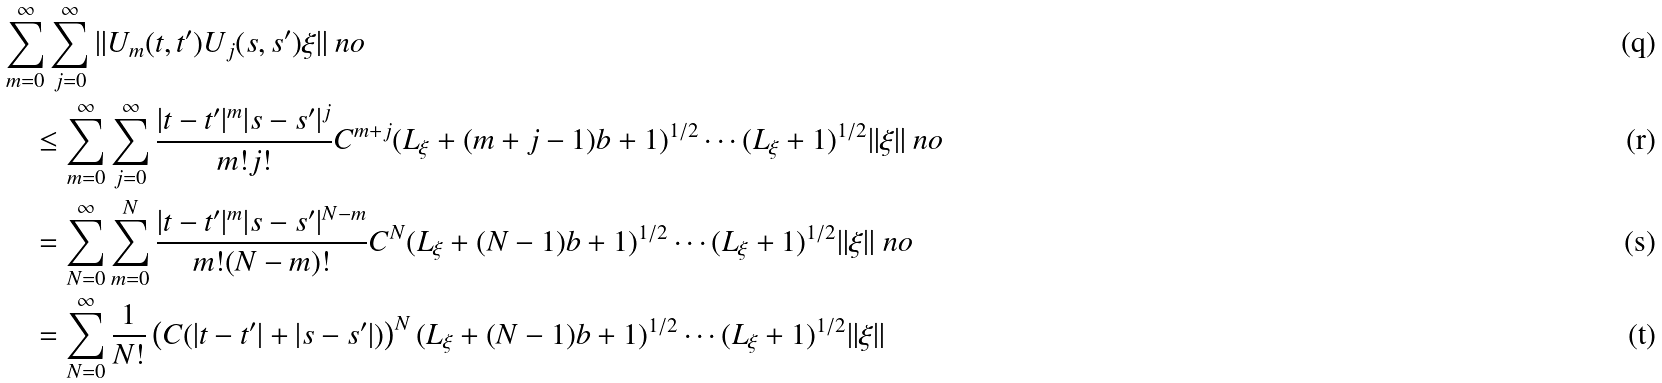<formula> <loc_0><loc_0><loc_500><loc_500>& \sum _ { m = 0 } ^ { \infty } \sum _ { j = 0 } ^ { \infty } \| U _ { m } ( t , t ^ { \prime } ) U _ { j } ( s , s ^ { \prime } ) \xi \| \ n o \\ & \quad \leq \sum _ { m = 0 } ^ { \infty } \sum _ { j = 0 } ^ { \infty } \frac { | t - t ^ { \prime } | ^ { m } | s - s ^ { \prime } | ^ { j } } { m ! j ! } C ^ { m + j } ( L _ { \xi } + ( m + j - 1 ) b + 1 ) ^ { 1 / 2 } \cdots ( L _ { \xi } + 1 ) ^ { 1 / 2 } \| \xi \| \ n o \\ & \quad = \sum _ { N = 0 } ^ { \infty } \sum _ { m = 0 } ^ { N } \frac { | t - t ^ { \prime } | ^ { m } | s - s ^ { \prime } | ^ { N - m } } { m ! ( N - m ) ! } C ^ { N } ( L _ { \xi } + ( N - 1 ) b + 1 ) ^ { 1 / 2 } \cdots ( L _ { \xi } + 1 ) ^ { 1 / 2 } \| \xi \| \ n o \\ & \quad = \sum _ { N = 0 } ^ { \infty } \frac { 1 } { N ! } \left ( C ( | t - t ^ { \prime } | + | s - s ^ { \prime } | ) \right ) ^ { N } ( L _ { \xi } + ( N - 1 ) b + 1 ) ^ { 1 / 2 } \cdots ( L _ { \xi } + 1 ) ^ { 1 / 2 } \| \xi \|</formula> 